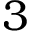Convert formula to latex. <formula><loc_0><loc_0><loc_500><loc_500>3</formula> 